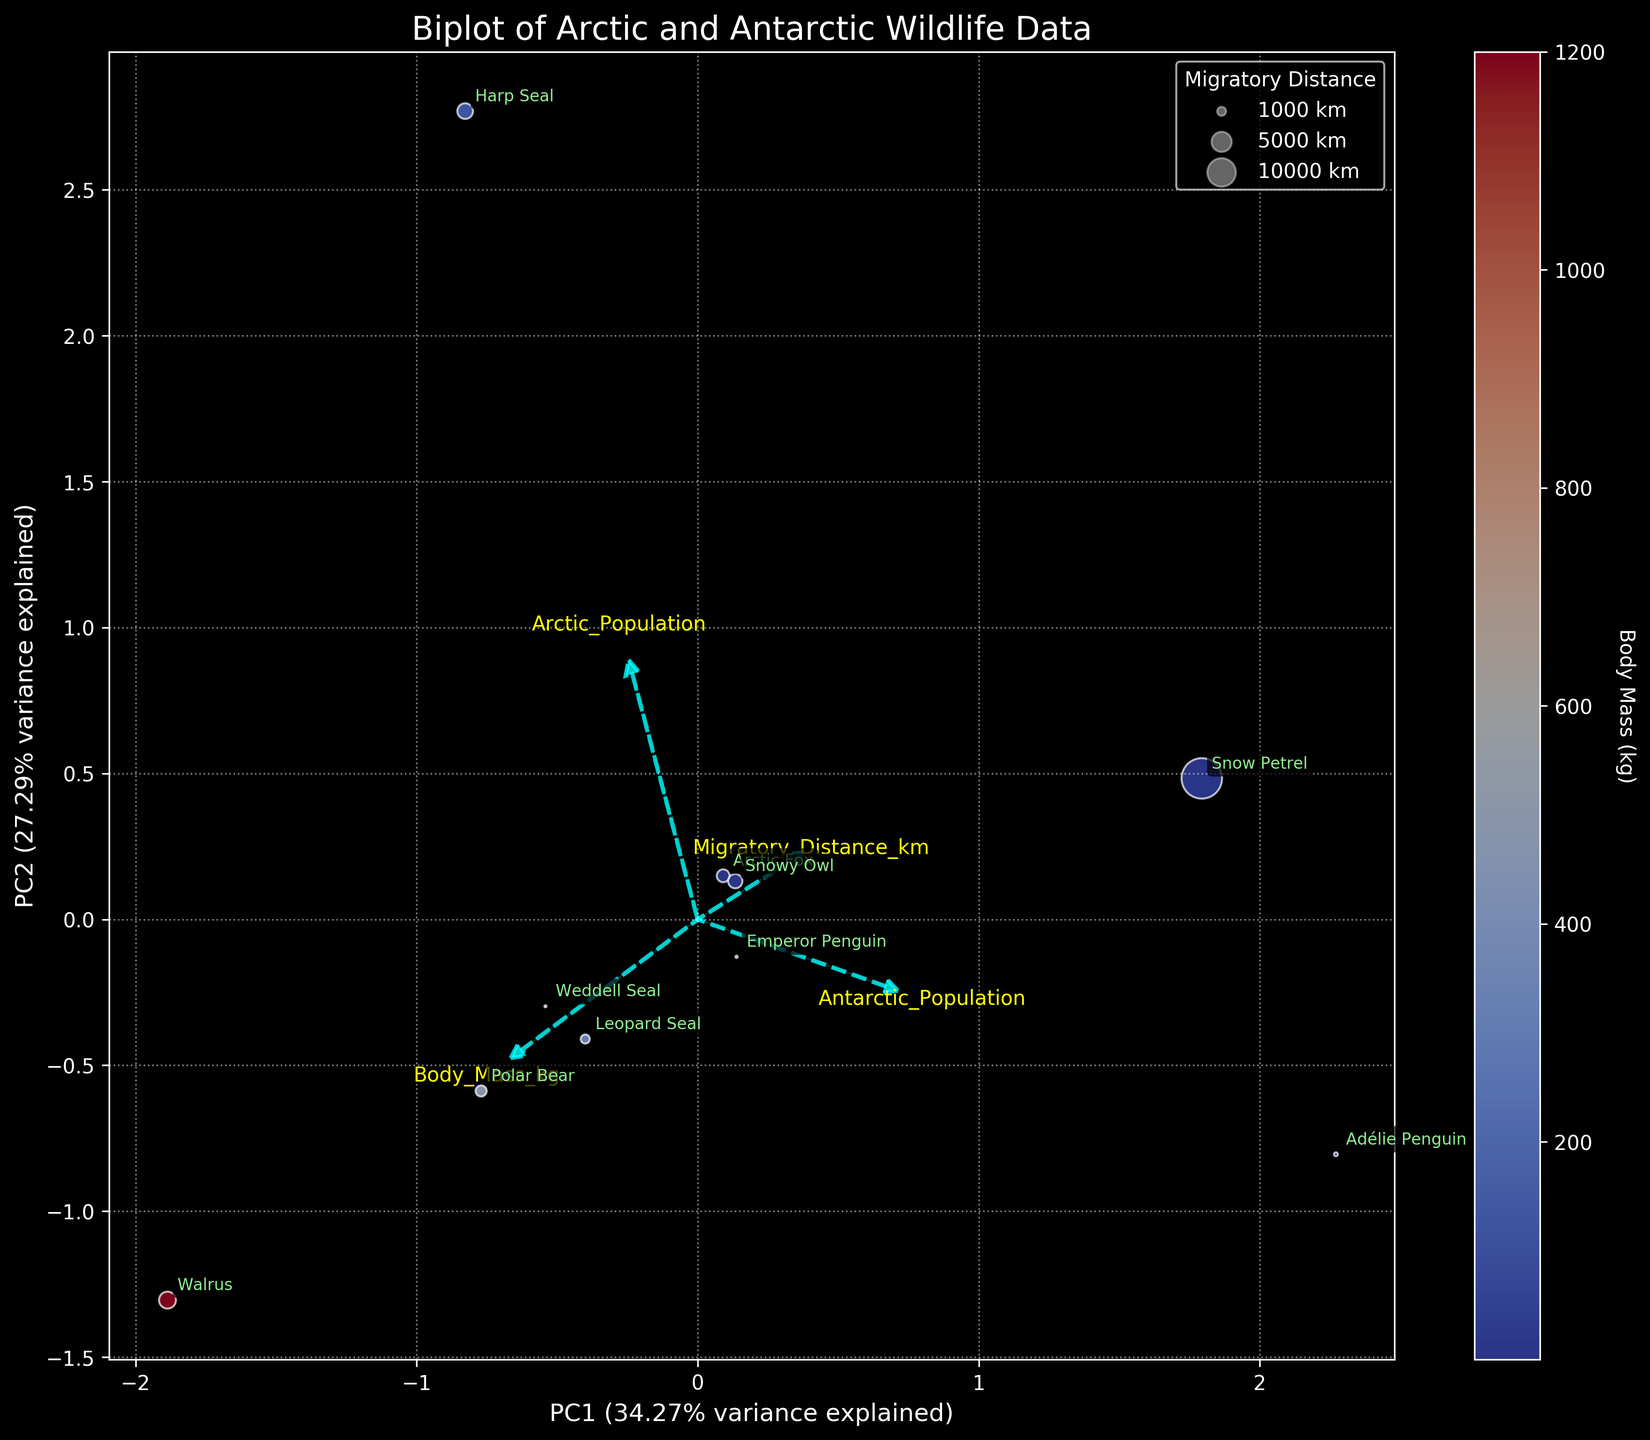How many species are represented in this plot? Count the number of unique species names annotated on the plot. There are 10 unique labels: Polar Bear, Emperor Penguin, Arctic Fox, Weddell Seal, Harp Seal, Adélie Penguin, Walrus, Leopard Seal, Snowy Owl, and Snow Petrel.
Answer: 10 What are the species with the highest and lowest body mass? Identify the color of the points representing body mass, as shown in the color bar. The Walrus has the highest body mass as it corresponds to the darkest point in the color scale (1200 kg), and Snow Petrel has the lowest body mass as it corresponds to the lightest point in the color scale (0.3 kg).
Answer: Walrus, Snow Petrel Which species show the longest and the shortest migratory distances? The size of the points indicates migratory distance, as explained by the legend with varying bubble sizes. The Snow Petrel shows the longest migratory distance indicated by the largest bubble (20000 km), and the Weddell Seal shows the shortest migratory distance indicated by the smallest bubble (50 km).
Answer: Snow Petrel, Weddell Seal How much variance is explained by the first principal component (PC1)? Look at the label of the x-axis, which denotes PC1 along with the variance it explains. The x-axis label indicates that PC1 explains 39.28% of the variance.
Answer: 39.28% Which feature vectors have the largest component along PC1? Identify the length of feature vectors along the x-axis (PC1). The 'Antarctic_Population' vector has the largest component along PC1 as it extends furthest in the positive x-direction.
Answer: Antarctic_Population Are the populations of Arctic and Antarctic species strongly correlated with each other? Analyze the angles between the vectors for 'Arctic_Population' and 'Antarctic_Population'. They are not pointed in the same direction, indicating a weak or negative correlation.
Answer: No Which species is closest to the origin in the biplot? Look for the species with a point closest to (0,0). The Snowy Owl is closest to the origin in the plot.
Answer: Snowy Owl How does the Arctic Fox compare to the Polar Bear in terms of body mass and migratory distance? Compare the color (body mass) and size (migratory distance) of the points for Arctic Fox and Polar Bear. Arctic Fox has a much lighter color (3.5 kg) and a larger bubble (2000 km) compared to Polar Bear, which is darker (500 kg) and has a smaller bubble (1500 km).
Answer: Arctic Fox is lighter and migrates farther What direction does the 'Body_Mass_kg' vector point in the biplot? Check the arrow direction for 'Body_Mass_kg'. It points towards the lower right (positive PC1 and negative or near-zero PC2), showing where higher body mass is represented in the plot.
Answer: Lower right Which two features are most closely aligned in the biplot? Look for feature vectors that are most aligned or point in nearly the same direction. 'Body_Mass_kg' and 'Arctic_Population' vectors are closely aligned in the plot, indicating a strong positive correlation.
Answer: Body_Mass_kg and Arctic_Population 